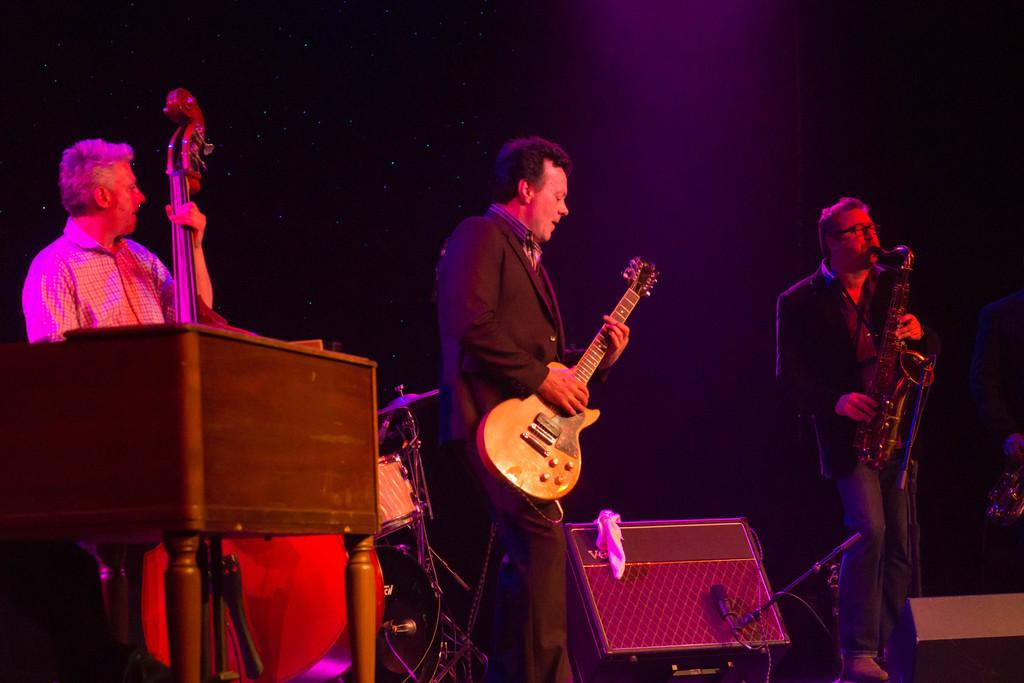How many people are in the image? There are three persons in the image. What are the persons doing in the image? The persons are standing and holding musical instruments in their hands. What objects are present in the image that are related to sound amplification? There are microphones in the image. What can be seen in the background of the image? There is a screen in the background of the image. What type of committee is visible in the image? There is no committee present in the image. Can you tell me how the stomach of the person on the left is feeling in the image? There is no information about the person's stomach in the image. 